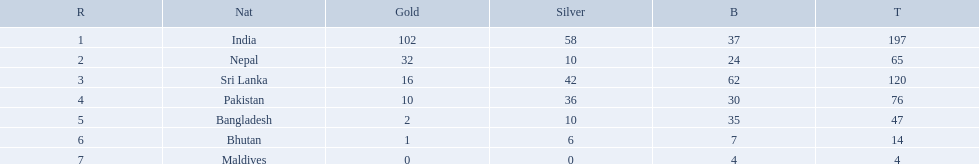Which countries won medals? India, Nepal, Sri Lanka, Pakistan, Bangladesh, Bhutan, Maldives. Which won the most? India. Which won the fewest? Maldives. What are the totals of medals one in each country? 197, 65, 120, 76, 47, 14, 4. Which of these totals are less than 10? 4. Who won this number of medals? Maldives. Write the full table. {'header': ['R', 'Nat', 'Gold', 'Silver', 'B', 'T'], 'rows': [['1', 'India', '102', '58', '37', '197'], ['2', 'Nepal', '32', '10', '24', '65'], ['3', 'Sri Lanka', '16', '42', '62', '120'], ['4', 'Pakistan', '10', '36', '30', '76'], ['5', 'Bangladesh', '2', '10', '35', '47'], ['6', 'Bhutan', '1', '6', '7', '14'], ['7', 'Maldives', '0', '0', '4', '4']]} What were the total amount won of medals by nations in the 1999 south asian games? 197, 65, 120, 76, 47, 14, 4. Which amount was the lowest? 4. Which nation had this amount? Maldives. How many gold medals were won by the teams? 102, 32, 16, 10, 2, 1, 0. What country won no gold medals? Maldives. What countries attended the 1999 south asian games? India, Nepal, Sri Lanka, Pakistan, Bangladesh, Bhutan, Maldives. Which of these countries had 32 gold medals? Nepal. Which nations played at the 1999 south asian games? India, Nepal, Sri Lanka, Pakistan, Bangladesh, Bhutan, Maldives. Which country is listed second in the table? Nepal. What are all the countries listed in the table? India, Nepal, Sri Lanka, Pakistan, Bangladesh, Bhutan, Maldives. Which of these is not india? Nepal, Sri Lanka, Pakistan, Bangladesh, Bhutan, Maldives. Of these, which is first? Nepal. 